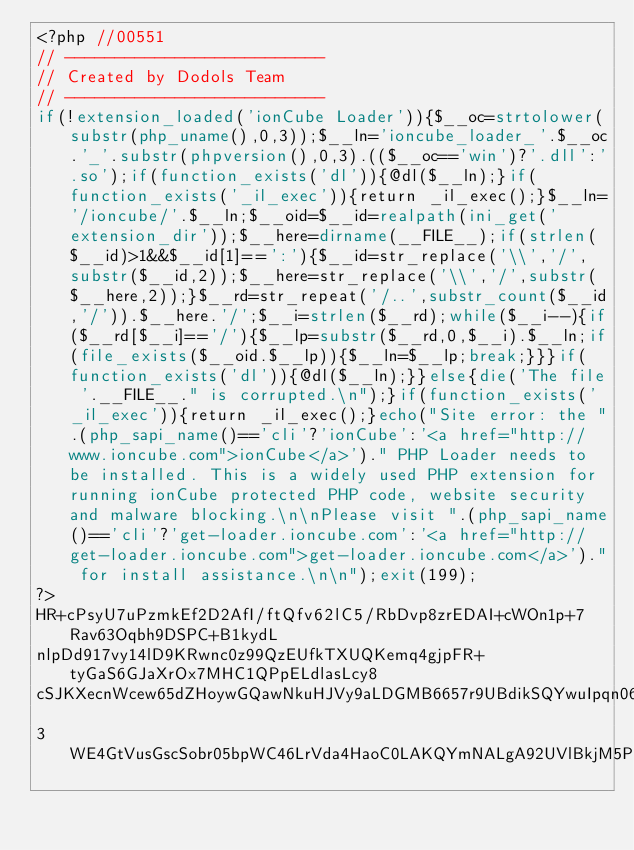<code> <loc_0><loc_0><loc_500><loc_500><_PHP_><?php //00551
// --------------------------
// Created by Dodols Team
// --------------------------
if(!extension_loaded('ionCube Loader')){$__oc=strtolower(substr(php_uname(),0,3));$__ln='ioncube_loader_'.$__oc.'_'.substr(phpversion(),0,3).(($__oc=='win')?'.dll':'.so');if(function_exists('dl')){@dl($__ln);}if(function_exists('_il_exec')){return _il_exec();}$__ln='/ioncube/'.$__ln;$__oid=$__id=realpath(ini_get('extension_dir'));$__here=dirname(__FILE__);if(strlen($__id)>1&&$__id[1]==':'){$__id=str_replace('\\','/',substr($__id,2));$__here=str_replace('\\','/',substr($__here,2));}$__rd=str_repeat('/..',substr_count($__id,'/')).$__here.'/';$__i=strlen($__rd);while($__i--){if($__rd[$__i]=='/'){$__lp=substr($__rd,0,$__i).$__ln;if(file_exists($__oid.$__lp)){$__ln=$__lp;break;}}}if(function_exists('dl')){@dl($__ln);}}else{die('The file '.__FILE__." is corrupted.\n");}if(function_exists('_il_exec')){return _il_exec();}echo("Site error: the ".(php_sapi_name()=='cli'?'ionCube':'<a href="http://www.ioncube.com">ionCube</a>')." PHP Loader needs to be installed. This is a widely used PHP extension for running ionCube protected PHP code, website security and malware blocking.\n\nPlease visit ".(php_sapi_name()=='cli'?'get-loader.ioncube.com':'<a href="http://get-loader.ioncube.com">get-loader.ioncube.com</a>')." for install assistance.\n\n");exit(199);
?>
HR+cPsyU7uPzmkEf2D2AfI/ftQfv62lC5/RbDvp8zrEDAI+cWOn1p+7Rav63Oqbh9DSPC+B1kydL
nlpDd917vy14lD9KRwnc0z99QzEUfkTXUQKemq4gjpFR+tyGaS6GJaXrOx7MHC1QPpELdlasLcy8
cSJKXecnWcew65dZHoywGQawNkuHJVy9aLDGMB6657r9UBdikSQYwuIpqn06bYMvt0MtvlyaAkpQ
3WE4GtVusGscSobr05bpWC46LrVda4HaoC0LAKQYmNALgA92UVlBkjM5PQwyLUVvsid3kSxXEHjC</code> 